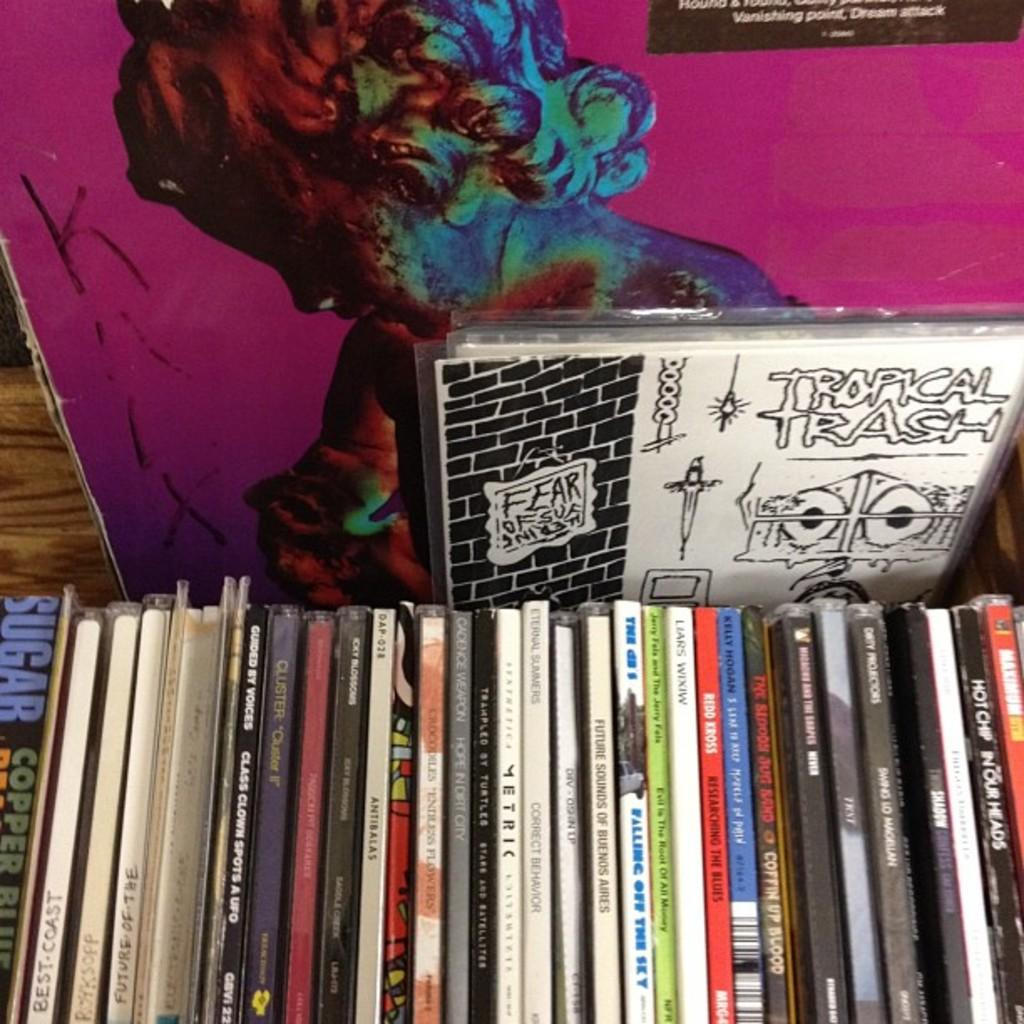What can be seen in the image? There are objects in the image. Can you describe one of the objects in the image? There is a board with a painting on it in the image. What is the board placed on? The board is on a wooden surface. What type of thunder can be heard in the image? There is no thunder present in the image, as it is a still image and does not contain any sound. 